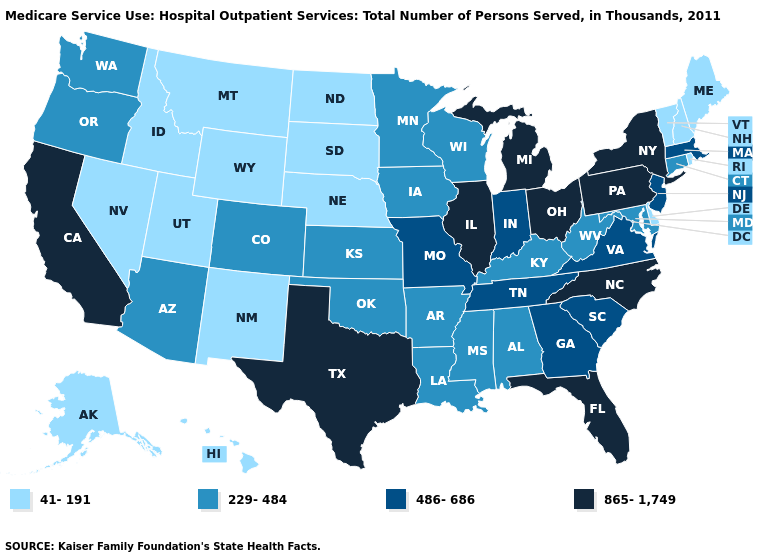Does Alabama have a lower value than Virginia?
Quick response, please. Yes. Name the states that have a value in the range 41-191?
Give a very brief answer. Alaska, Delaware, Hawaii, Idaho, Maine, Montana, Nebraska, Nevada, New Hampshire, New Mexico, North Dakota, Rhode Island, South Dakota, Utah, Vermont, Wyoming. Name the states that have a value in the range 865-1,749?
Quick response, please. California, Florida, Illinois, Michigan, New York, North Carolina, Ohio, Pennsylvania, Texas. Name the states that have a value in the range 865-1,749?
Quick response, please. California, Florida, Illinois, Michigan, New York, North Carolina, Ohio, Pennsylvania, Texas. Among the states that border Wyoming , does Montana have the highest value?
Quick response, please. No. Name the states that have a value in the range 865-1,749?
Concise answer only. California, Florida, Illinois, Michigan, New York, North Carolina, Ohio, Pennsylvania, Texas. Does Michigan have the highest value in the USA?
Keep it brief. Yes. What is the highest value in states that border Oregon?
Be succinct. 865-1,749. Does New Mexico have a lower value than South Carolina?
Answer briefly. Yes. Name the states that have a value in the range 486-686?
Write a very short answer. Georgia, Indiana, Massachusetts, Missouri, New Jersey, South Carolina, Tennessee, Virginia. Does Delaware have the lowest value in the USA?
Write a very short answer. Yes. Does the map have missing data?
Answer briefly. No. What is the lowest value in the South?
Be succinct. 41-191. Does Hawaii have a lower value than Kansas?
Short answer required. Yes. What is the value of Delaware?
Keep it brief. 41-191. 